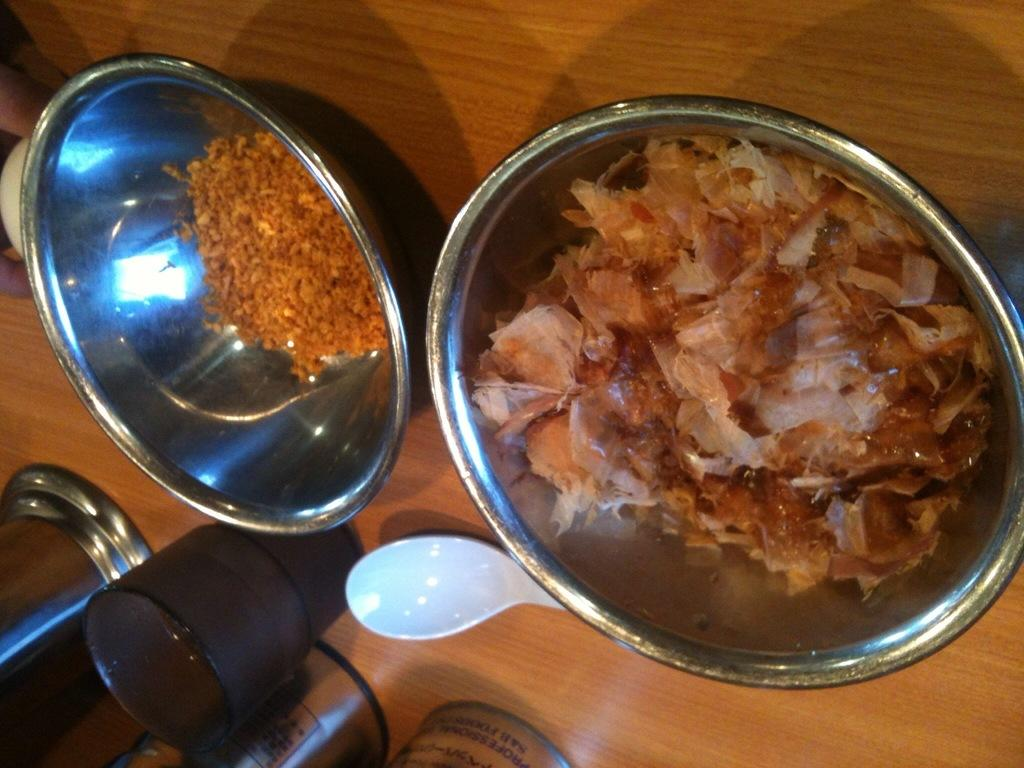What type of containers are the food items kept in? The food items are kept in steel bowls. What utensil can be seen in the image? There is a white-colored spoon in the image. What type of dish is present in the image? There is a glass in the image. On what surface are the food items and other objects placed? The objects are placed on a wooden table. What type of crime is being committed in the image? There is no crime or criminal activity depicted in the image. The image shows food items, steel bowls, a white-colored spoon, a glass, and a wooden table. 